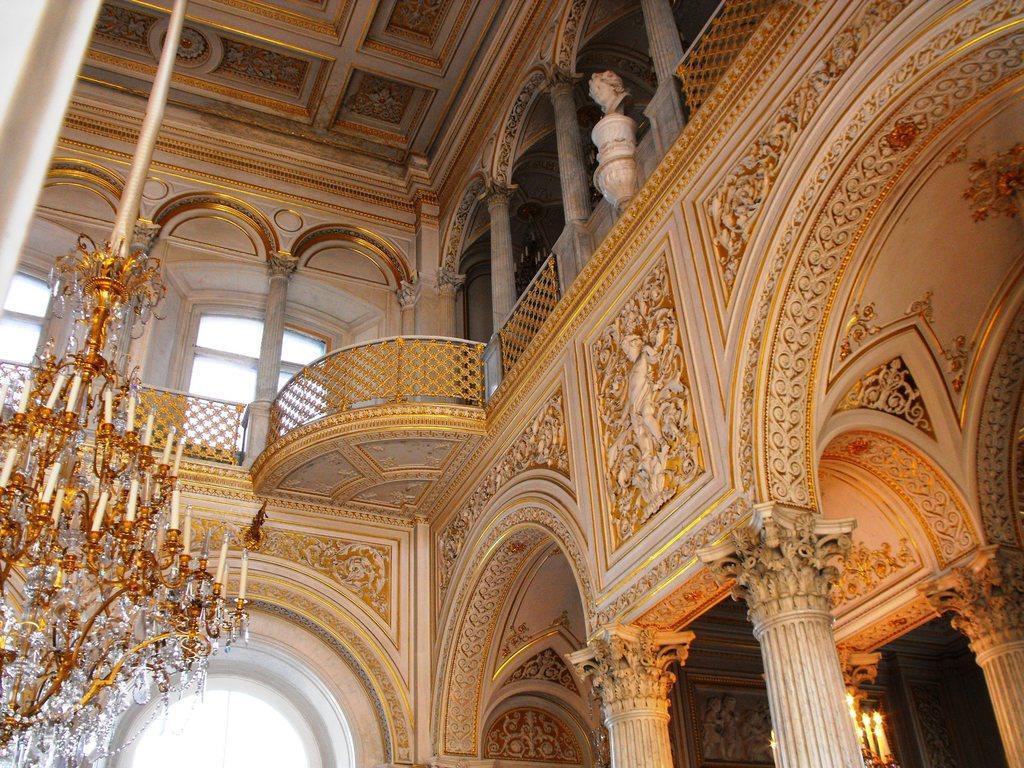Please provide a concise description of this image. An inside picture of a building. Here we can see chandelier, pillars, fence, statue and designed walls. 